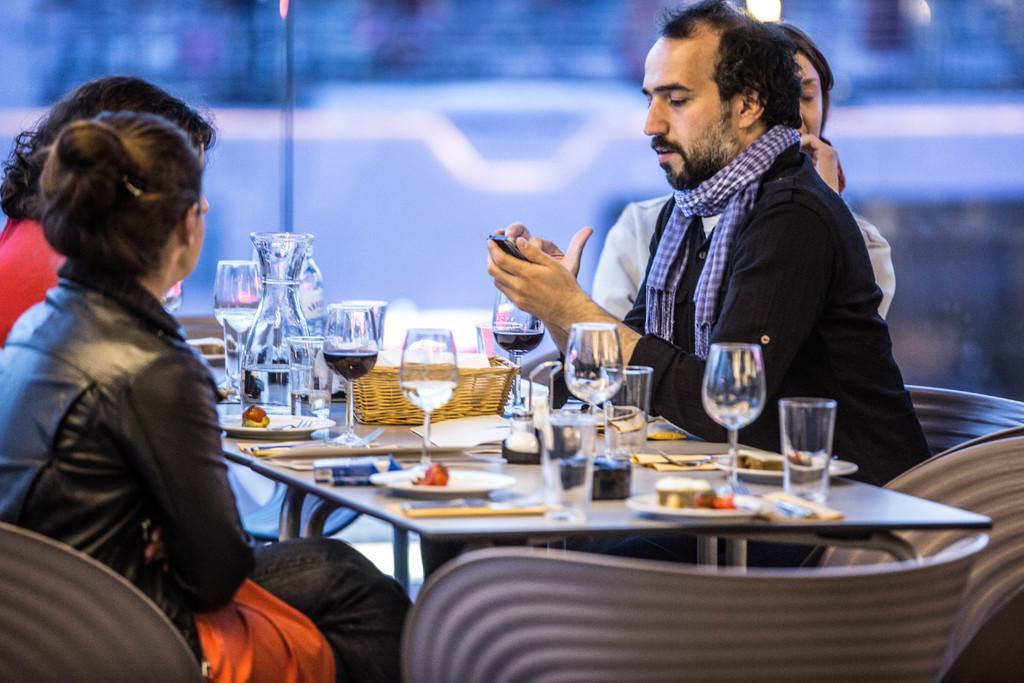How would you summarize this image in a sentence or two? There are four persons sitting on the table. One is male and other three are females and there are glasses which contains wine on the table, and the male guy is operating his phone and woman behind this male looking other side 